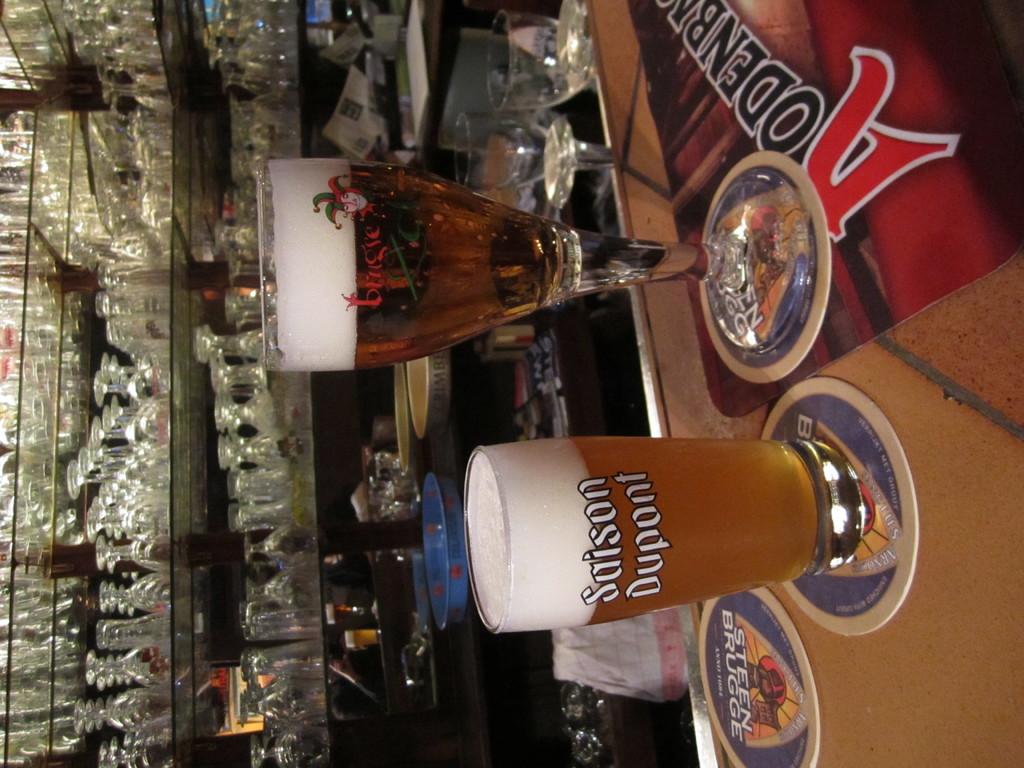What brand of beer is this?
Ensure brevity in your answer.  Saison dupont. What does the coaster say?
Make the answer very short. Steen brugge. 